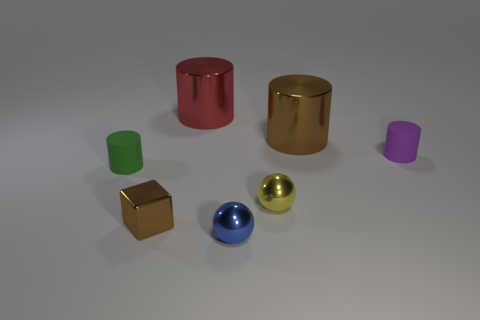Do the matte object that is in front of the tiny purple cylinder and the big cylinder that is on the right side of the tiny blue metallic thing have the same color?
Make the answer very short. No. The small green rubber thing has what shape?
Ensure brevity in your answer.  Cylinder. Is the number of big brown cylinders in front of the small brown shiny cube greater than the number of big brown shiny things?
Your response must be concise. No. The metallic object in front of the tiny brown metal object has what shape?
Your response must be concise. Sphere. How many other objects are there of the same shape as the big brown shiny thing?
Your answer should be compact. 3. Is the material of the brown thing that is behind the purple matte cylinder the same as the small yellow object?
Ensure brevity in your answer.  Yes. Are there the same number of big shiny things that are in front of the red shiny cylinder and blue spheres left of the small brown metal object?
Offer a terse response. No. There is a object on the right side of the brown shiny cylinder; how big is it?
Offer a very short reply. Small. Are there any purple cubes that have the same material as the yellow thing?
Your response must be concise. No. Is the color of the rubber cylinder left of the red shiny cylinder the same as the shiny cube?
Provide a succinct answer. No. 